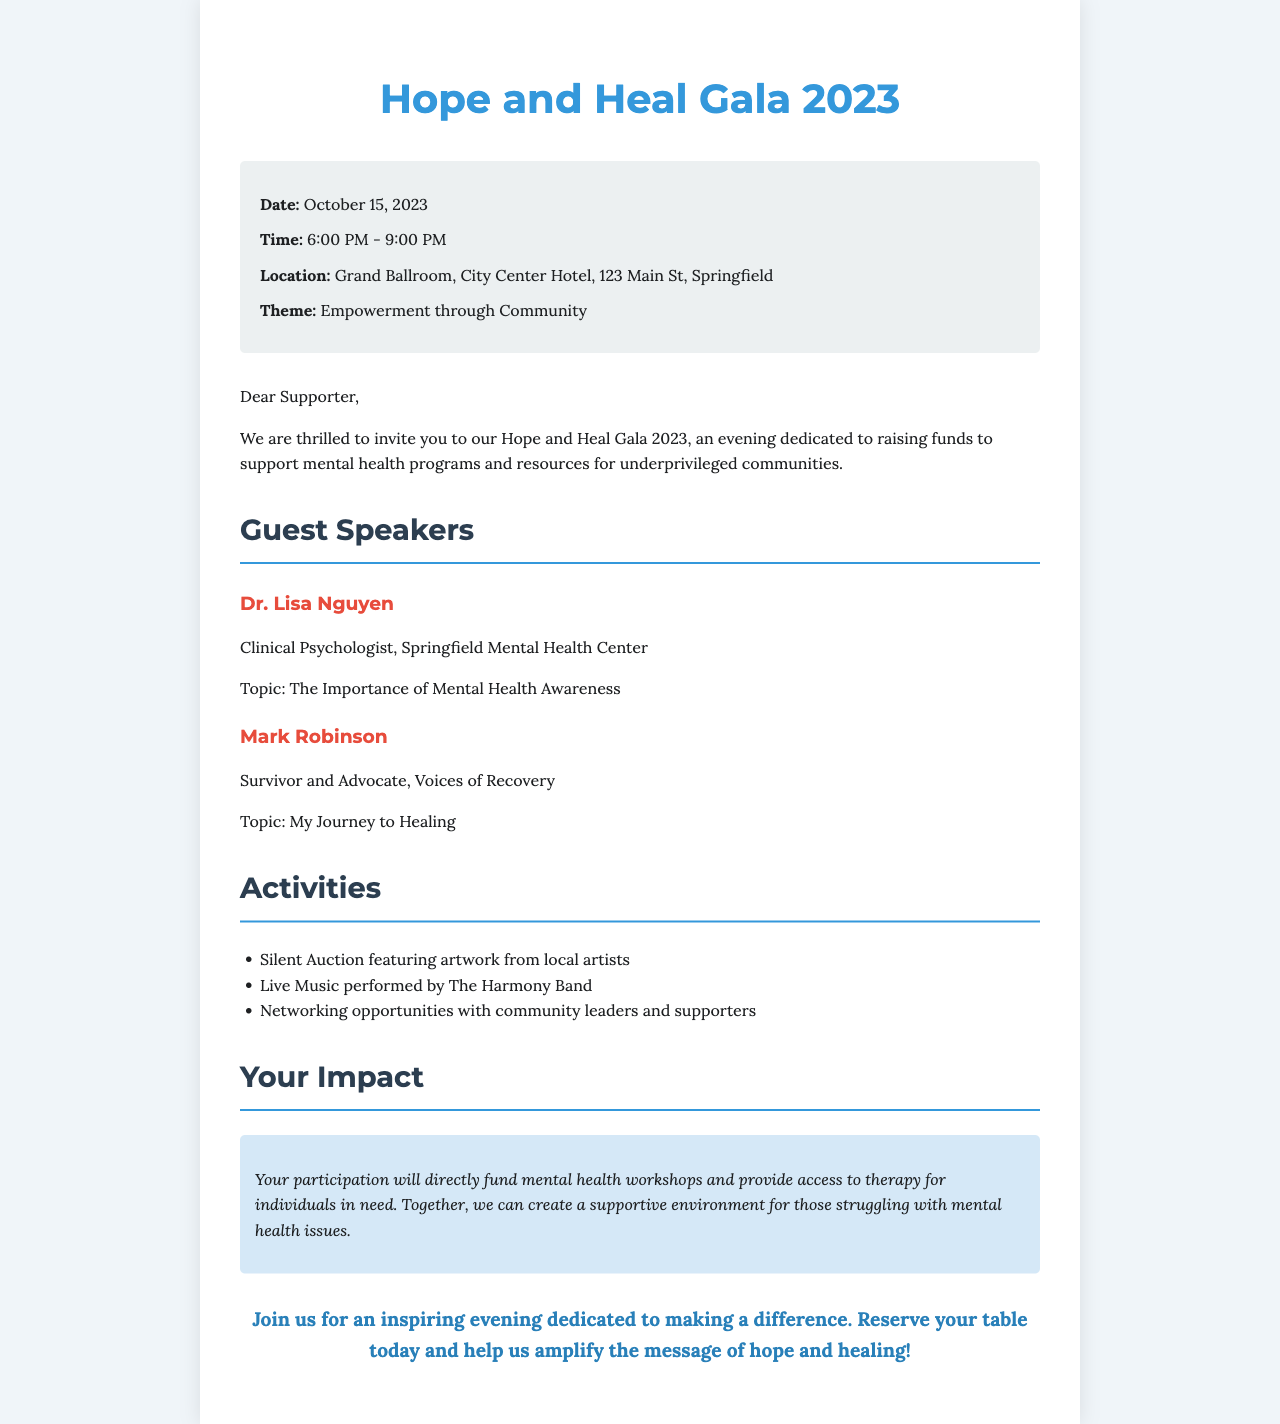What is the date of the event? The date of the event is clearly stated in the document, which is October 15, 2023.
Answer: October 15, 2023 Who is one of the guest speakers? The document lists guest speakers, including Dr. Lisa Nguyen as one of them.
Answer: Dr. Lisa Nguyen What is the theme of the gala? The theme for the gala is mentioned in the document as "Empowerment through Community."
Answer: Empowerment through Community How long is the gala scheduled to last? The time duration of the event is specified as 6:00 PM to 9:00 PM, which is a total of 3 hours.
Answer: 3 hours What type of auction will be featured? The document mentions a Silent Auction featuring artwork from local artists.
Answer: Silent Auction What is a significant outcome of participating in the event? The document states that participation will directly fund mental health workshops and provide therapy access.
Answer: Fund mental health workshops Where is the event taking place? The location for the event is found in the details, specifically at the Grand Ballroom, City Center Hotel.
Answer: Grand Ballroom, City Center Hotel Who is the second guest speaker and what topic will they discuss? The second speaker mentioned is Mark Robinson, who will discuss "My Journey to Healing."
Answer: Mark Robinson; My Journey to Healing 